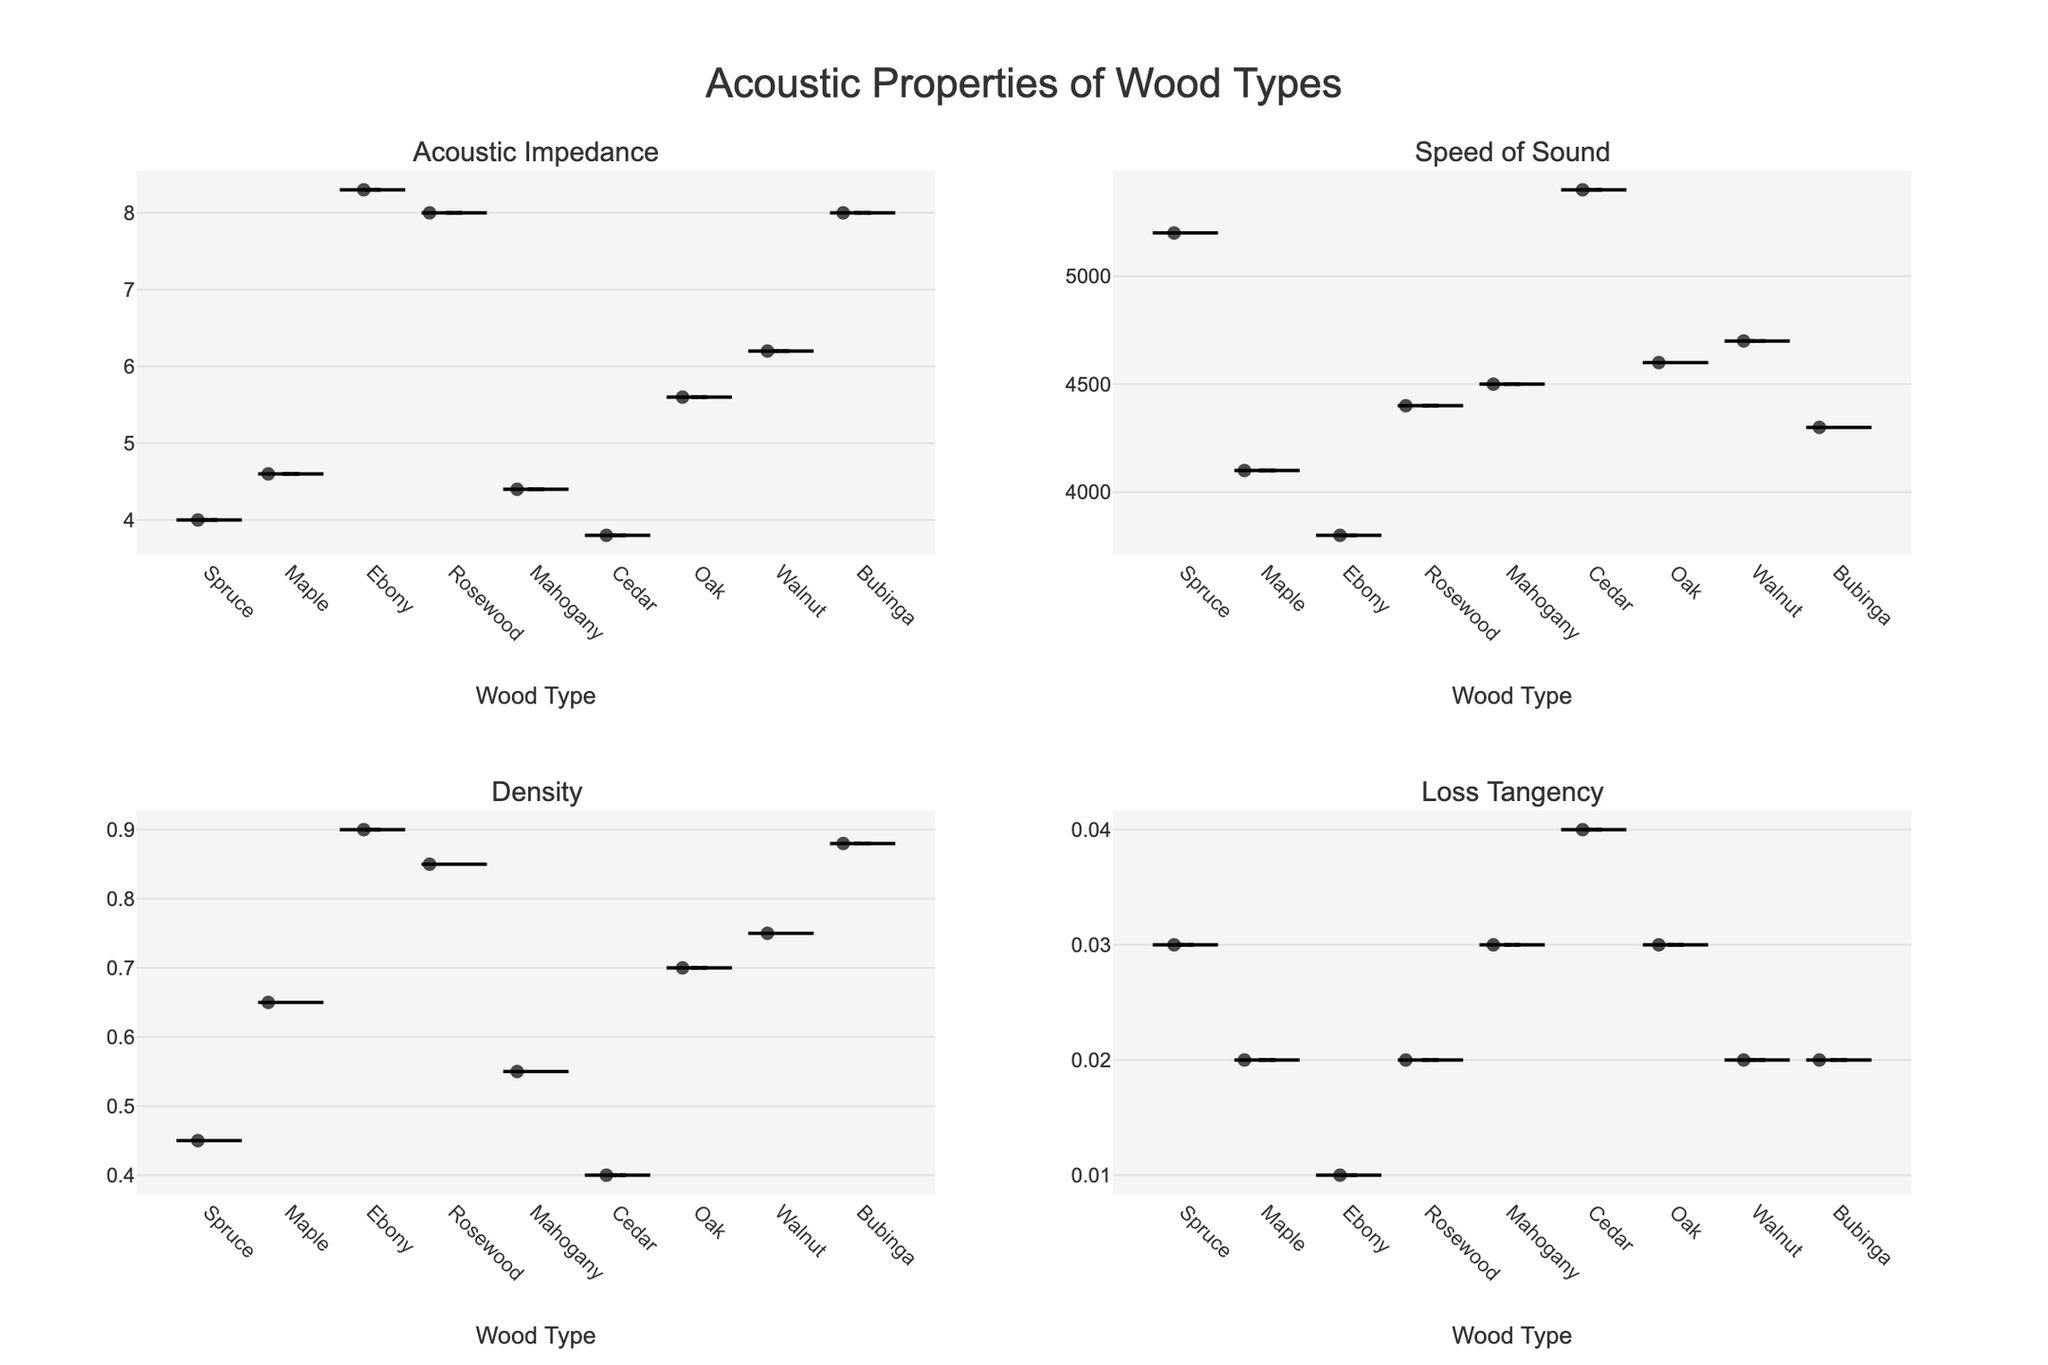What is the title of the figure? The title is usually located at the top center of the figure. In this case, it reads "Acoustic Properties of Wood Types".
Answer: Acoustic Properties of Wood Types Which wood type has the highest acoustic impedance? Look at the first subplot titled "Acoustic Impedance". Ebony has the highest value noted visually from the violin plot.
Answer: Ebony How many subplots are there in the figure? The layout of the figure includes 2 rows and 2 columns of plots. This totals to 4 subplots.
Answer: 4 What is the range of speed of sound values across different wood types? By observing the second subplot titled "Speed of Sound", we can see the minimum value around 3800 and the maximum value around 5400. The range can be calculated as 5400 - 3800.
Answer: 1600 Which wood type has the highest density? Check the third subplot titled "Density". Visually, Ebony has the highest density.
Answer: Ebony How does the loss tangency compare between wood types? Examine the fourth subplot titled "Loss Tangency". This measures the loss of energy in oscillatory systems. Cedar has the highest loss tangency value, while Ebony has the lowest.
Answer: Cedar has the highest, Ebony has the lowest List the wood types with a speed of sound greater than 4500. From the "Speed of Sound" subplot, identify points higher than 4500. Cedar and Spruce have values greater than 4500.
Answer: Cedar, Spruce What wood type combines a relatively low density with a high speed of sound? Check "Density" and "Speed of Sound" subplots. Spruce has a low density and high speed of sound values, making it the correct answer.
Answer: Spruce Which wood types have both their density values and loss tangency values? Examine the subplots for "Density" and "Loss Tangency". All wood types have density and loss tangency values.
Answer: All wood types Do any wood types have both the highest and lowest values in any single acoustic property? Compare each subplot: Ebony has the highest density and lowest loss tangency.
Answer: Yes, Ebony in density and loss tangency 